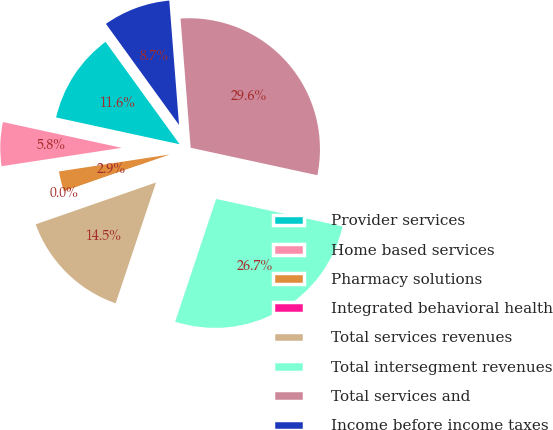<chart> <loc_0><loc_0><loc_500><loc_500><pie_chart><fcel>Provider services<fcel>Home based services<fcel>Pharmacy solutions<fcel>Integrated behavioral health<fcel>Total services revenues<fcel>Total intersegment revenues<fcel>Total services and<fcel>Income before income taxes<nl><fcel>11.63%<fcel>5.82%<fcel>2.91%<fcel>0.0%<fcel>14.54%<fcel>26.73%<fcel>29.64%<fcel>8.72%<nl></chart> 